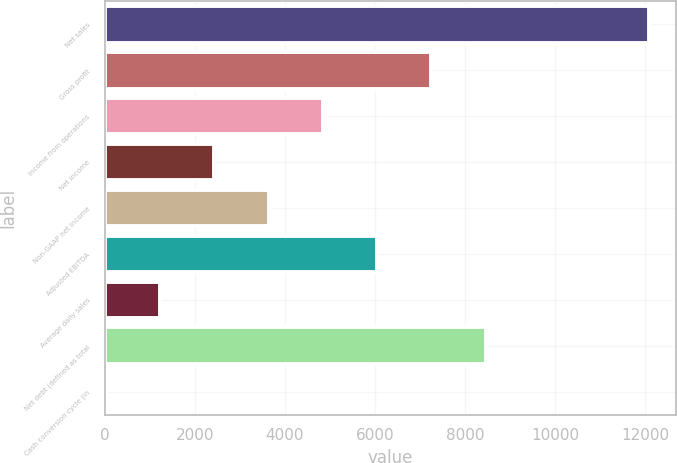Convert chart to OTSL. <chart><loc_0><loc_0><loc_500><loc_500><bar_chart><fcel>Net sales<fcel>Gross profit<fcel>Income from operations<fcel>Net income<fcel>Non-GAAP net income<fcel>Adjusted EBITDA<fcel>Average daily sales<fcel>Net debt (defined as total<fcel>Cash conversion cycle (in<nl><fcel>12074.5<fcel>7253.1<fcel>4842.4<fcel>2431.7<fcel>3637.05<fcel>6047.75<fcel>1226.35<fcel>8458.45<fcel>21<nl></chart> 